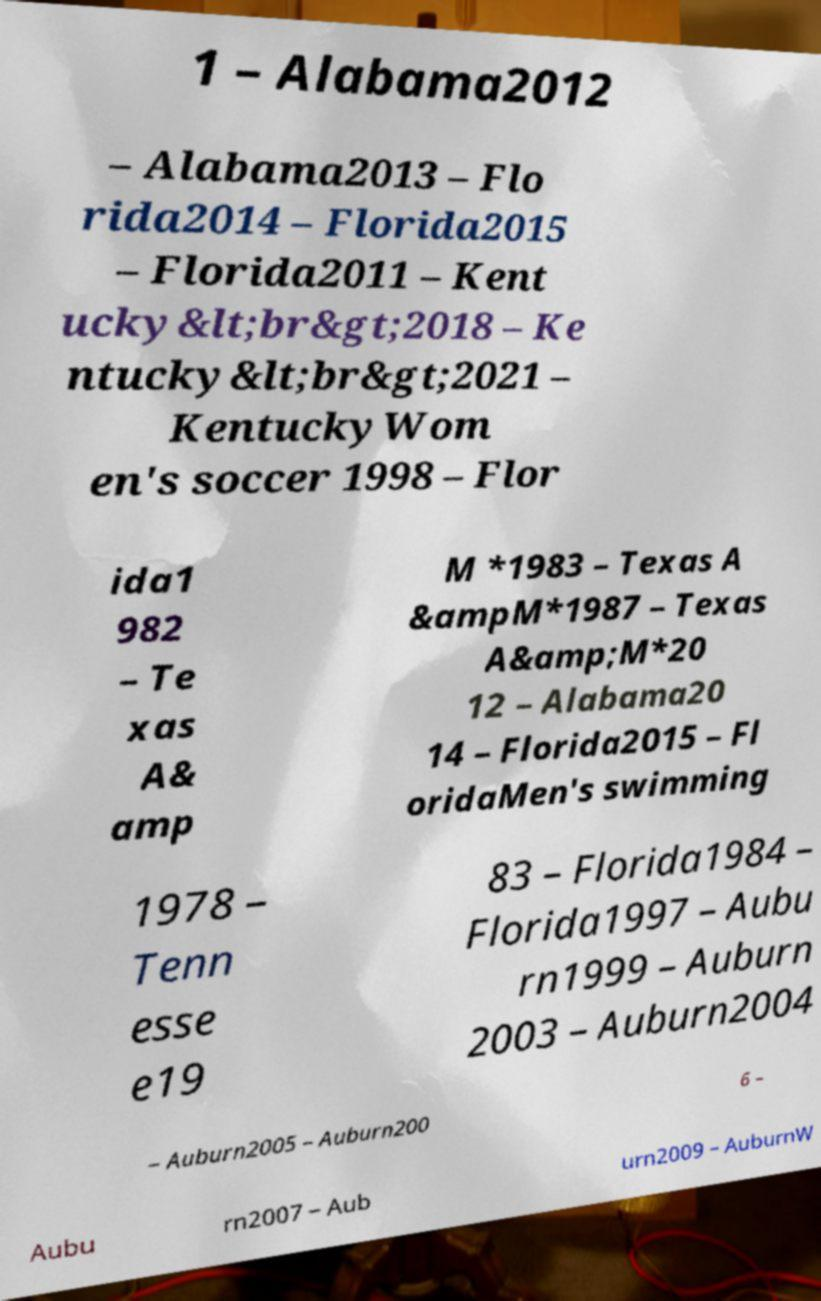I need the written content from this picture converted into text. Can you do that? 1 – Alabama2012 – Alabama2013 – Flo rida2014 – Florida2015 – Florida2011 – Kent ucky&lt;br&gt;2018 – Ke ntucky&lt;br&gt;2021 – KentuckyWom en's soccer 1998 – Flor ida1 982 – Te xas A& amp M *1983 – Texas A &ampM*1987 – Texas A&amp;M*20 12 – Alabama20 14 – Florida2015 – Fl oridaMen's swimming 1978 – Tenn esse e19 83 – Florida1984 – Florida1997 – Aubu rn1999 – Auburn 2003 – Auburn2004 – Auburn2005 – Auburn200 6 – Aubu rn2007 – Aub urn2009 – AuburnW 